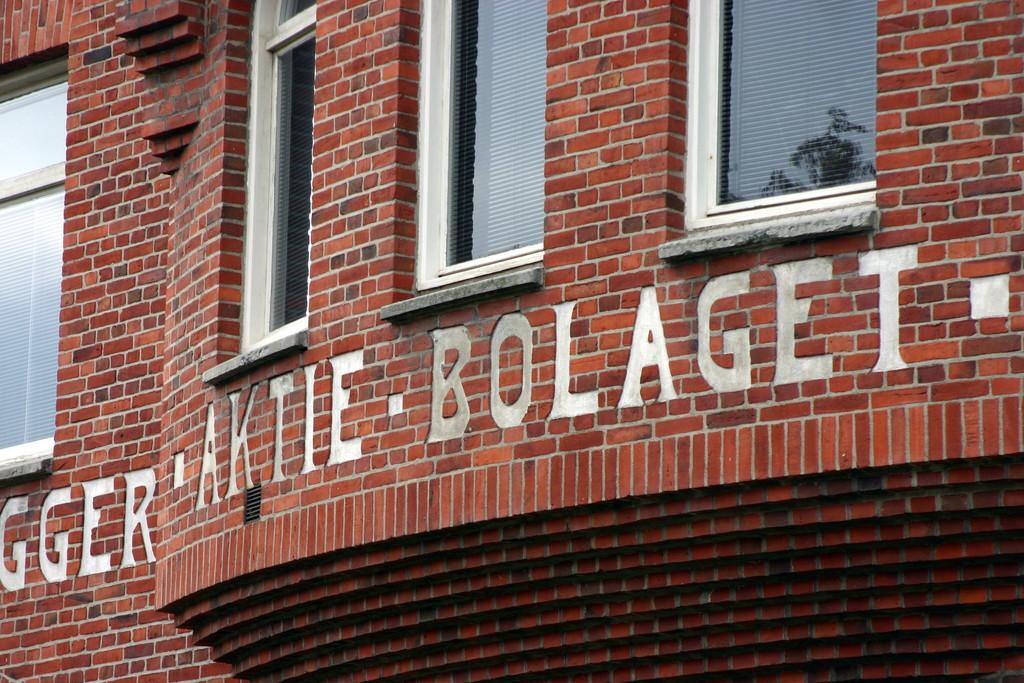What is the main subject of the picture? The main subject of the picture is a building. What features can be observed on the building? The building has windows and there is writing on the building. How many police officers are patrolling the street in the image? There are no police officers or streets present in the image; it only features a building with windows and writing. What type of watch is visible on the building in the image? There is no watch present on the building in the image. 